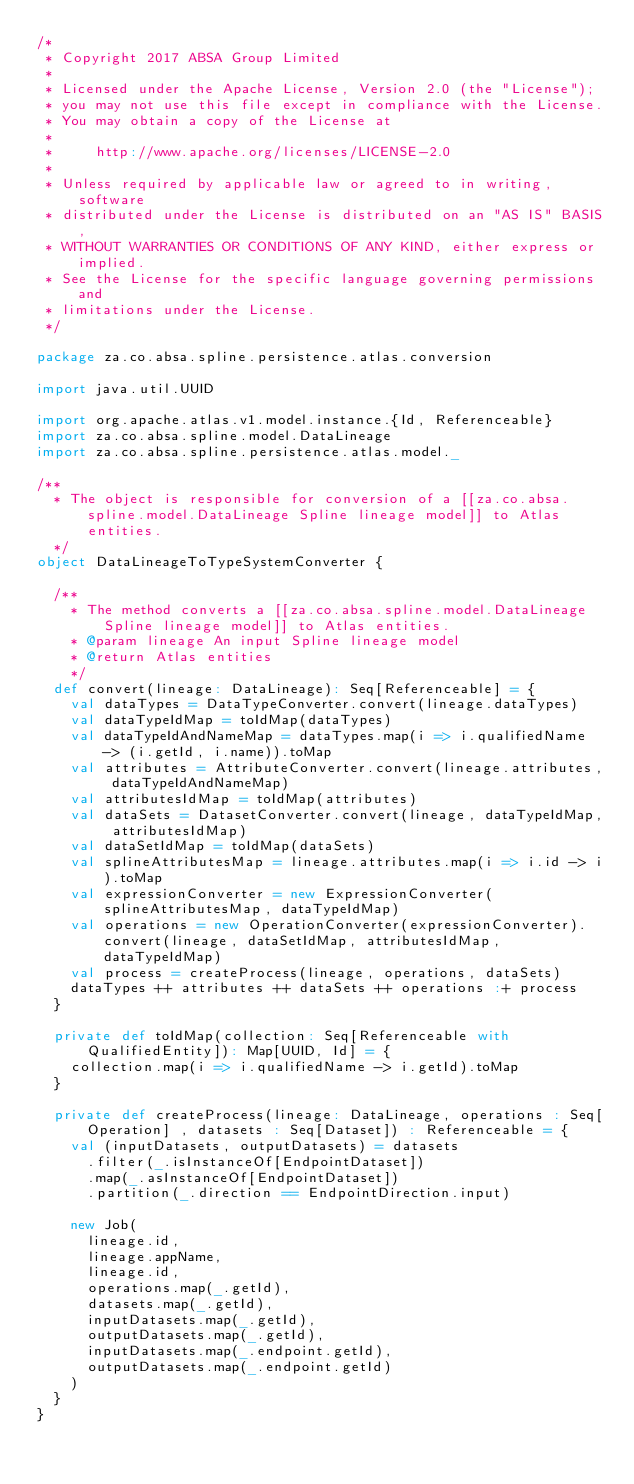<code> <loc_0><loc_0><loc_500><loc_500><_Scala_>/*
 * Copyright 2017 ABSA Group Limited
 *
 * Licensed under the Apache License, Version 2.0 (the "License");
 * you may not use this file except in compliance with the License.
 * You may obtain a copy of the License at
 *
 *     http://www.apache.org/licenses/LICENSE-2.0
 *
 * Unless required by applicable law or agreed to in writing, software
 * distributed under the License is distributed on an "AS IS" BASIS,
 * WITHOUT WARRANTIES OR CONDITIONS OF ANY KIND, either express or implied.
 * See the License for the specific language governing permissions and
 * limitations under the License.
 */

package za.co.absa.spline.persistence.atlas.conversion

import java.util.UUID

import org.apache.atlas.v1.model.instance.{Id, Referenceable}
import za.co.absa.spline.model.DataLineage
import za.co.absa.spline.persistence.atlas.model._

/**
  * The object is responsible for conversion of a [[za.co.absa.spline.model.DataLineage Spline lineage model]] to Atlas entities.
  */
object DataLineageToTypeSystemConverter {

  /**
    * The method converts a [[za.co.absa.spline.model.DataLineage Spline lineage model]] to Atlas entities.
    * @param lineage An input Spline lineage model
    * @return Atlas entities
    */
  def convert(lineage: DataLineage): Seq[Referenceable] = {
    val dataTypes = DataTypeConverter.convert(lineage.dataTypes)
    val dataTypeIdMap = toIdMap(dataTypes)
    val dataTypeIdAndNameMap = dataTypes.map(i => i.qualifiedName -> (i.getId, i.name)).toMap
    val attributes = AttributeConverter.convert(lineage.attributes, dataTypeIdAndNameMap)
    val attributesIdMap = toIdMap(attributes)
    val dataSets = DatasetConverter.convert(lineage, dataTypeIdMap, attributesIdMap)
    val dataSetIdMap = toIdMap(dataSets)
    val splineAttributesMap = lineage.attributes.map(i => i.id -> i).toMap
    val expressionConverter = new ExpressionConverter(splineAttributesMap, dataTypeIdMap)
    val operations = new OperationConverter(expressionConverter).convert(lineage, dataSetIdMap, attributesIdMap, dataTypeIdMap)
    val process = createProcess(lineage, operations, dataSets)
    dataTypes ++ attributes ++ dataSets ++ operations :+ process
  }

  private def toIdMap(collection: Seq[Referenceable with QualifiedEntity]): Map[UUID, Id] = {
    collection.map(i => i.qualifiedName -> i.getId).toMap
  }

  private def createProcess(lineage: DataLineage, operations : Seq[Operation] , datasets : Seq[Dataset]) : Referenceable = {
    val (inputDatasets, outputDatasets) = datasets
      .filter(_.isInstanceOf[EndpointDataset])
      .map(_.asInstanceOf[EndpointDataset])
      .partition(_.direction == EndpointDirection.input)

    new Job(
      lineage.id,
      lineage.appName,
      lineage.id,
      operations.map(_.getId),
      datasets.map(_.getId),
      inputDatasets.map(_.getId),
      outputDatasets.map(_.getId),
      inputDatasets.map(_.endpoint.getId),
      outputDatasets.map(_.endpoint.getId)
    )
  }
}
</code> 